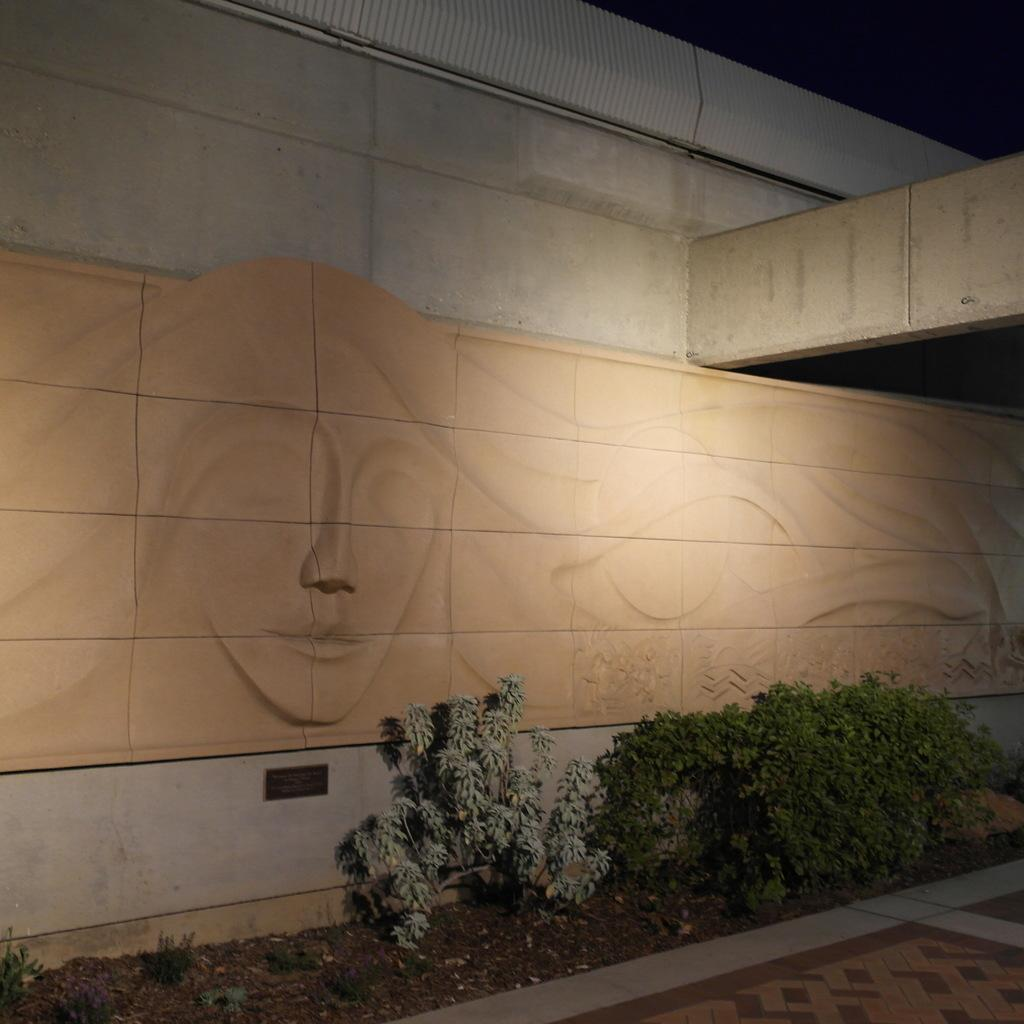What type of living organisms can be seen in the image? Plants can be seen in the image. What is visible in the background of the image? There is a building in the background of the image. Can you describe the design on the wall? The design on the wall resembles a wall sculpture. How many pears are hanging from the wall sculpture in the image? There are no pears present in the image; the design on the wall resembles a wall sculpture, but it does not include any pears. 